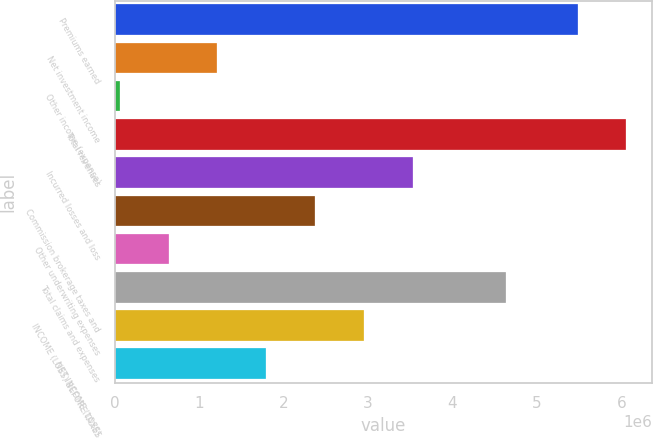Convert chart. <chart><loc_0><loc_0><loc_500><loc_500><bar_chart><fcel>Premiums earned<fcel>Net investment income<fcel>Other income (expense)<fcel>Total revenues<fcel>Incurred losses and loss<fcel>Commission brokerage taxes and<fcel>Other underwriting expenses<fcel>Total claims and expenses<fcel>INCOME (LOSS) BEFORE TAXES<fcel>NET INCOME (LOSS)<nl><fcel>5.48146e+06<fcel>1.21593e+06<fcel>60435<fcel>6.0592e+06<fcel>3.52691e+06<fcel>2.37142e+06<fcel>638180<fcel>4.62938e+06<fcel>2.94916e+06<fcel>1.79367e+06<nl></chart> 